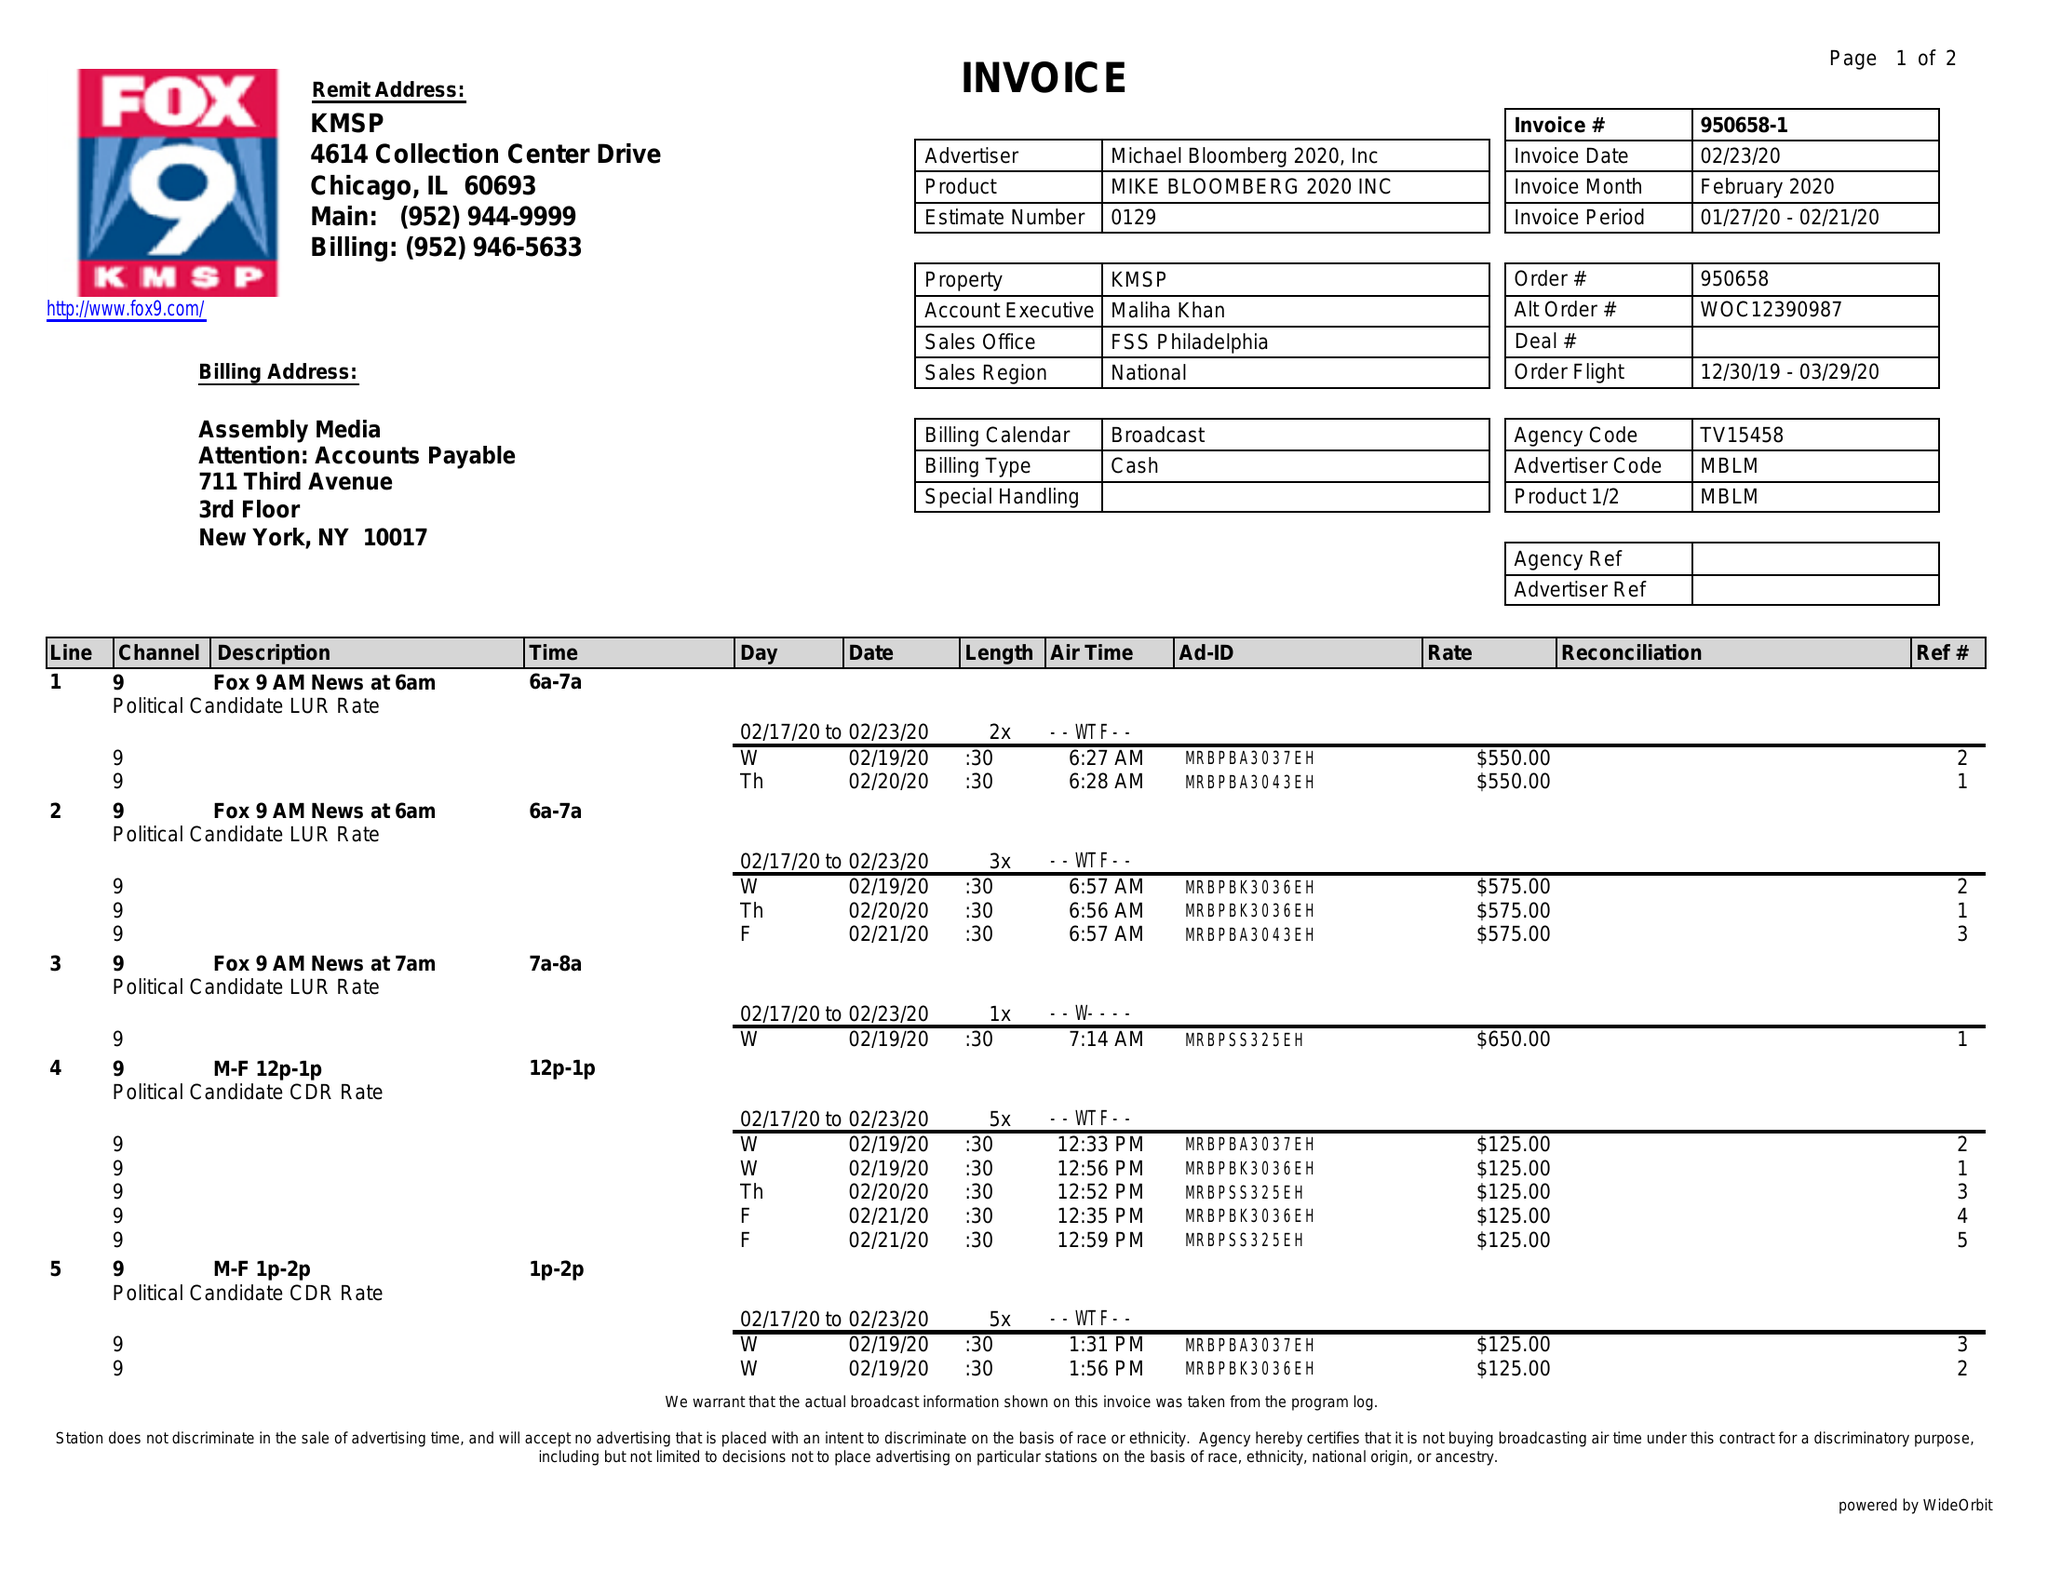What is the value for the gross_amount?
Answer the question using a single word or phrase. 5625.00 